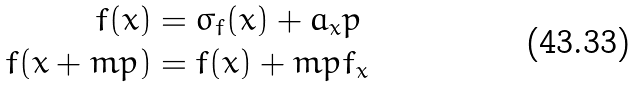Convert formula to latex. <formula><loc_0><loc_0><loc_500><loc_500>f ( x ) & = \sigma _ { f } ( x ) + a _ { x } p \\ f ( x + m p ) & = f ( x ) + m p f _ { x }</formula> 